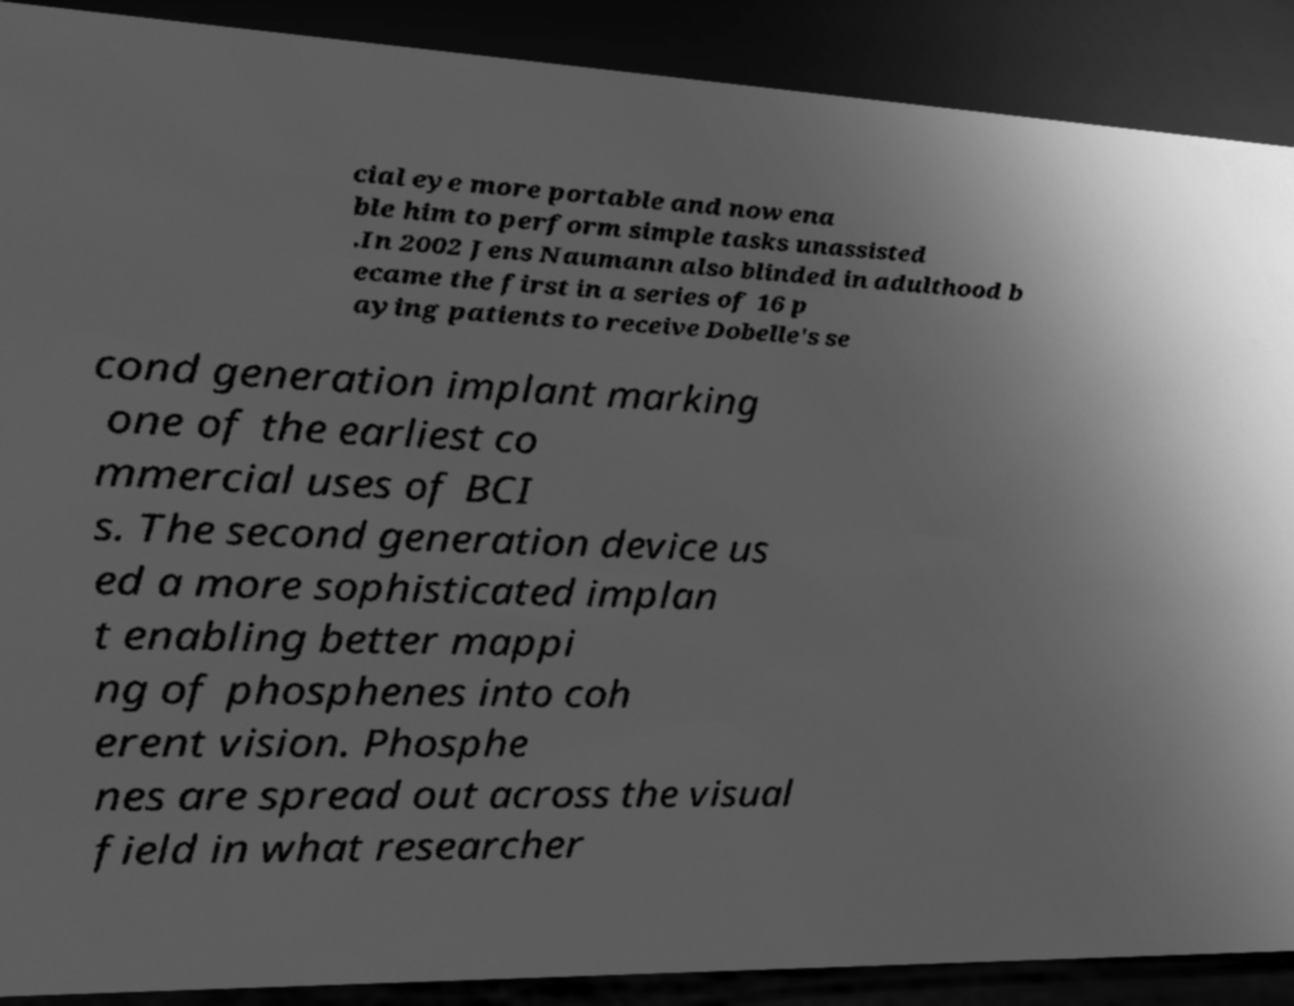For documentation purposes, I need the text within this image transcribed. Could you provide that? cial eye more portable and now ena ble him to perform simple tasks unassisted .In 2002 Jens Naumann also blinded in adulthood b ecame the first in a series of 16 p aying patients to receive Dobelle's se cond generation implant marking one of the earliest co mmercial uses of BCI s. The second generation device us ed a more sophisticated implan t enabling better mappi ng of phosphenes into coh erent vision. Phosphe nes are spread out across the visual field in what researcher 